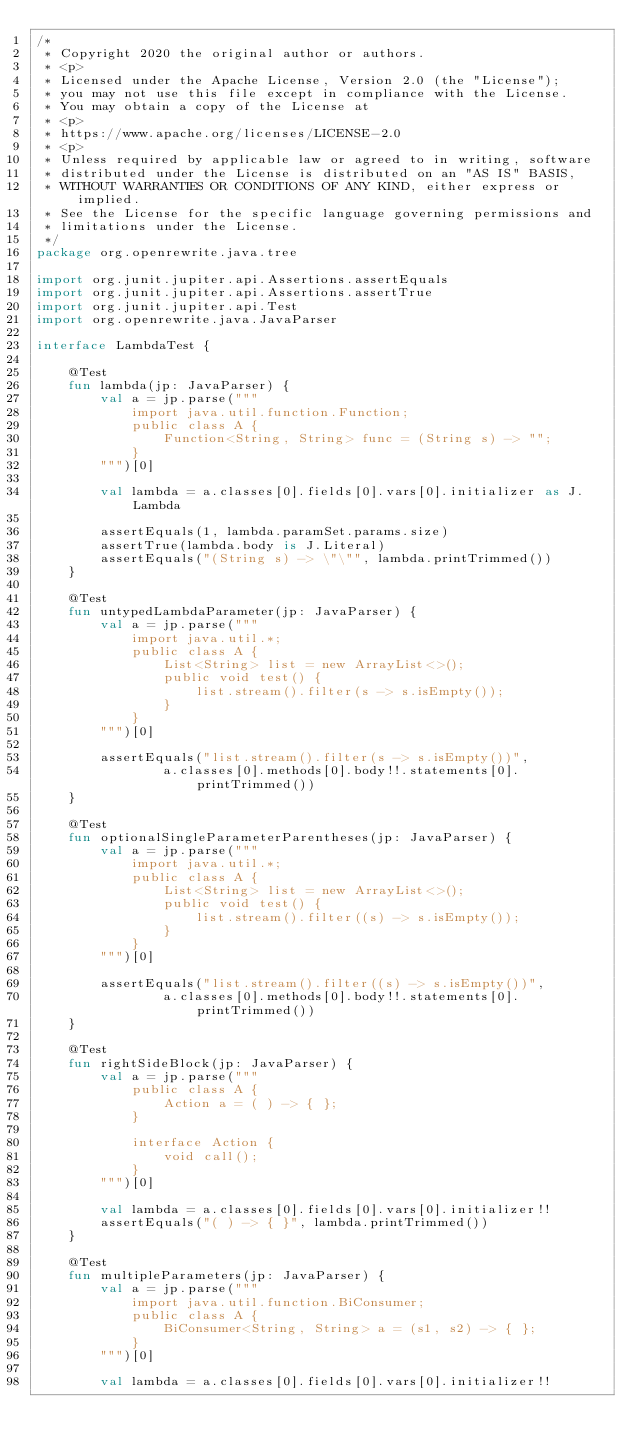Convert code to text. <code><loc_0><loc_0><loc_500><loc_500><_Kotlin_>/*
 * Copyright 2020 the original author or authors.
 * <p>
 * Licensed under the Apache License, Version 2.0 (the "License");
 * you may not use this file except in compliance with the License.
 * You may obtain a copy of the License at
 * <p>
 * https://www.apache.org/licenses/LICENSE-2.0
 * <p>
 * Unless required by applicable law or agreed to in writing, software
 * distributed under the License is distributed on an "AS IS" BASIS,
 * WITHOUT WARRANTIES OR CONDITIONS OF ANY KIND, either express or implied.
 * See the License for the specific language governing permissions and
 * limitations under the License.
 */
package org.openrewrite.java.tree

import org.junit.jupiter.api.Assertions.assertEquals
import org.junit.jupiter.api.Assertions.assertTrue
import org.junit.jupiter.api.Test
import org.openrewrite.java.JavaParser

interface LambdaTest {

    @Test
    fun lambda(jp: JavaParser) {
        val a = jp.parse("""
            import java.util.function.Function;
            public class A {
                Function<String, String> func = (String s) -> "";
            }
        """)[0]

        val lambda = a.classes[0].fields[0].vars[0].initializer as J.Lambda

        assertEquals(1, lambda.paramSet.params.size)
        assertTrue(lambda.body is J.Literal)
        assertEquals("(String s) -> \"\"", lambda.printTrimmed())
    }

    @Test
    fun untypedLambdaParameter(jp: JavaParser) {
        val a = jp.parse("""
            import java.util.*;
            public class A {
                List<String> list = new ArrayList<>();
                public void test() {
                    list.stream().filter(s -> s.isEmpty());
                }
            }
        """)[0]

        assertEquals("list.stream().filter(s -> s.isEmpty())",
                a.classes[0].methods[0].body!!.statements[0].printTrimmed())
    }

    @Test
    fun optionalSingleParameterParentheses(jp: JavaParser) {
        val a = jp.parse("""
            import java.util.*;
            public class A {
                List<String> list = new ArrayList<>();
                public void test() {
                    list.stream().filter((s) -> s.isEmpty());
                }
            }
        """)[0]

        assertEquals("list.stream().filter((s) -> s.isEmpty())",
                a.classes[0].methods[0].body!!.statements[0].printTrimmed())
    }

    @Test
    fun rightSideBlock(jp: JavaParser) {
        val a = jp.parse("""
            public class A {
                Action a = ( ) -> { };
            }

            interface Action {
                void call();
            }
        """)[0]

        val lambda = a.classes[0].fields[0].vars[0].initializer!!
        assertEquals("( ) -> { }", lambda.printTrimmed())
    }

    @Test
    fun multipleParameters(jp: JavaParser) {
        val a = jp.parse("""
            import java.util.function.BiConsumer;
            public class A {
                BiConsumer<String, String> a = (s1, s2) -> { };
            }
        """)[0]

        val lambda = a.classes[0].fields[0].vars[0].initializer!!</code> 